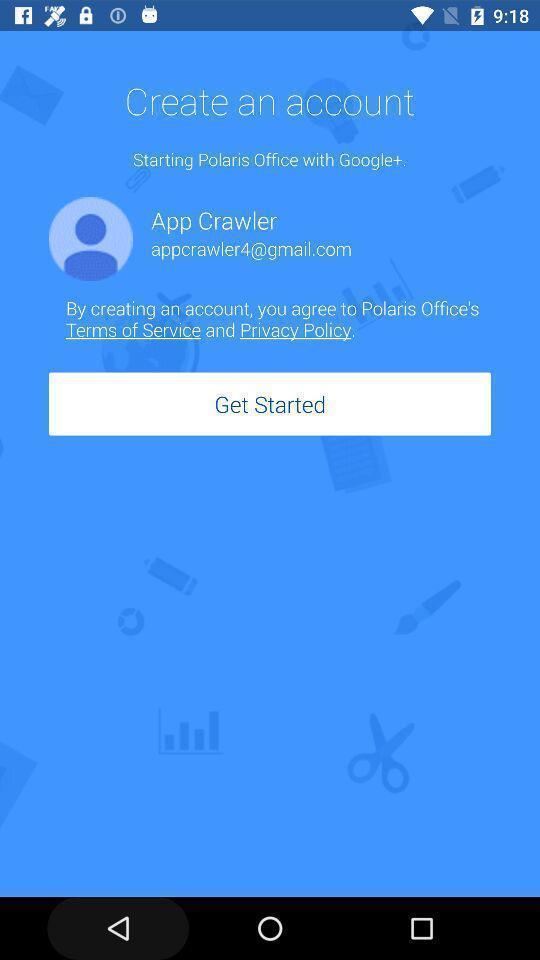Tell me about the visual elements in this screen capture. Welcome page. 